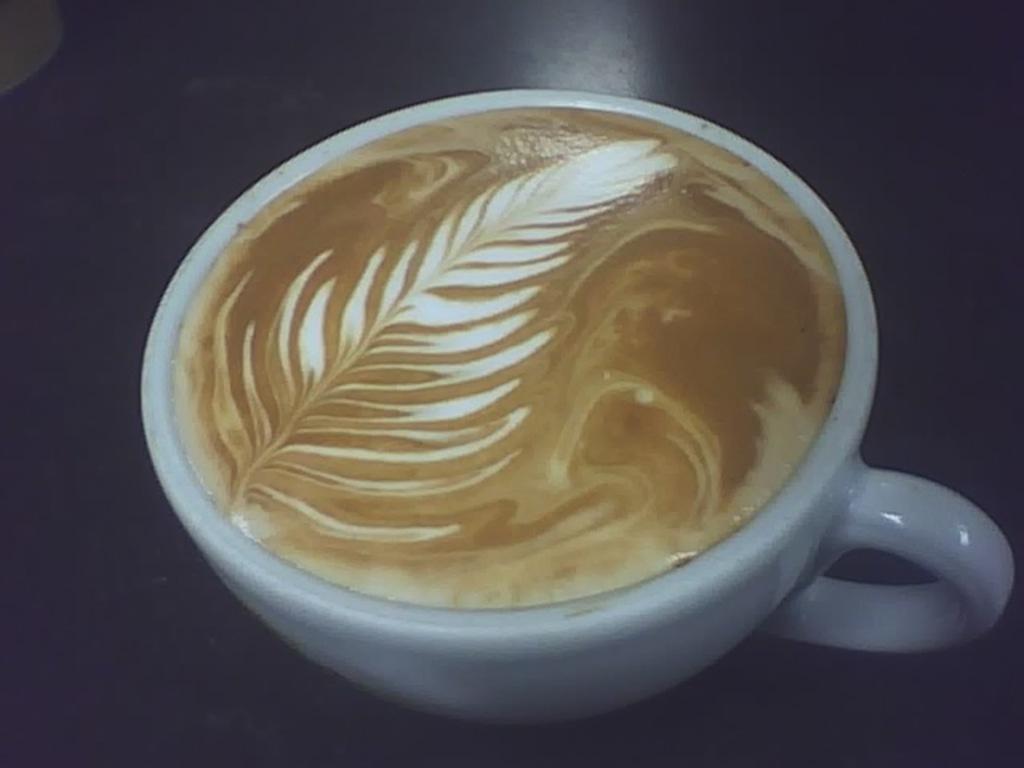In one or two sentences, can you explain what this image depicts? In this picture I can observe coffee in a cup. The cup is in white color. 